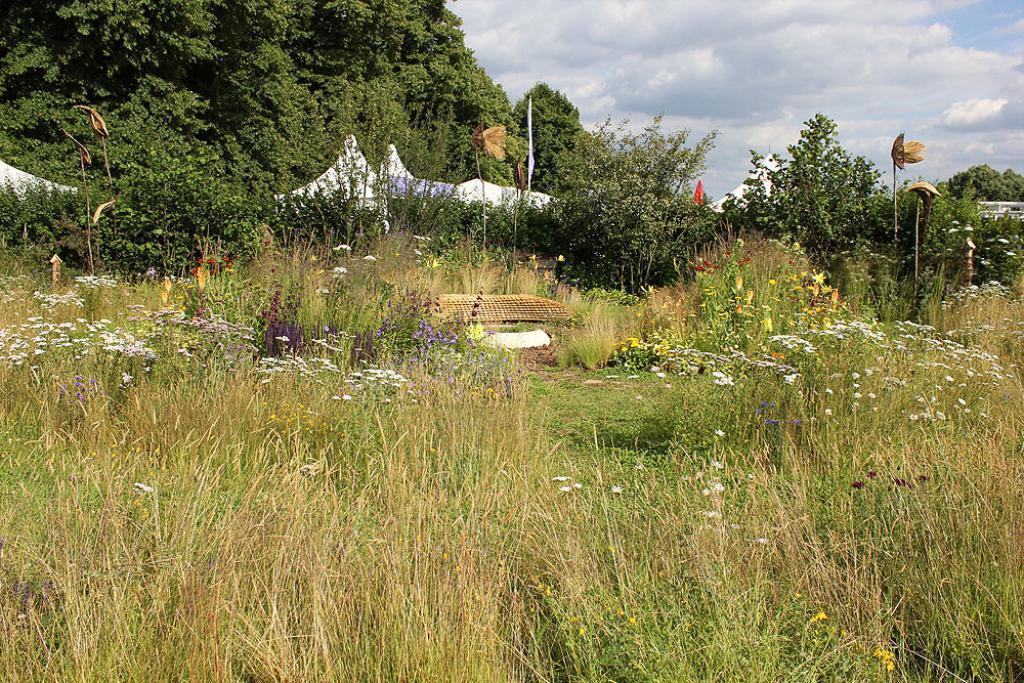Can you describe this image briefly? In this image we can see grass, flowers, small plants, tents, trees and the sky with clouds in the background. 